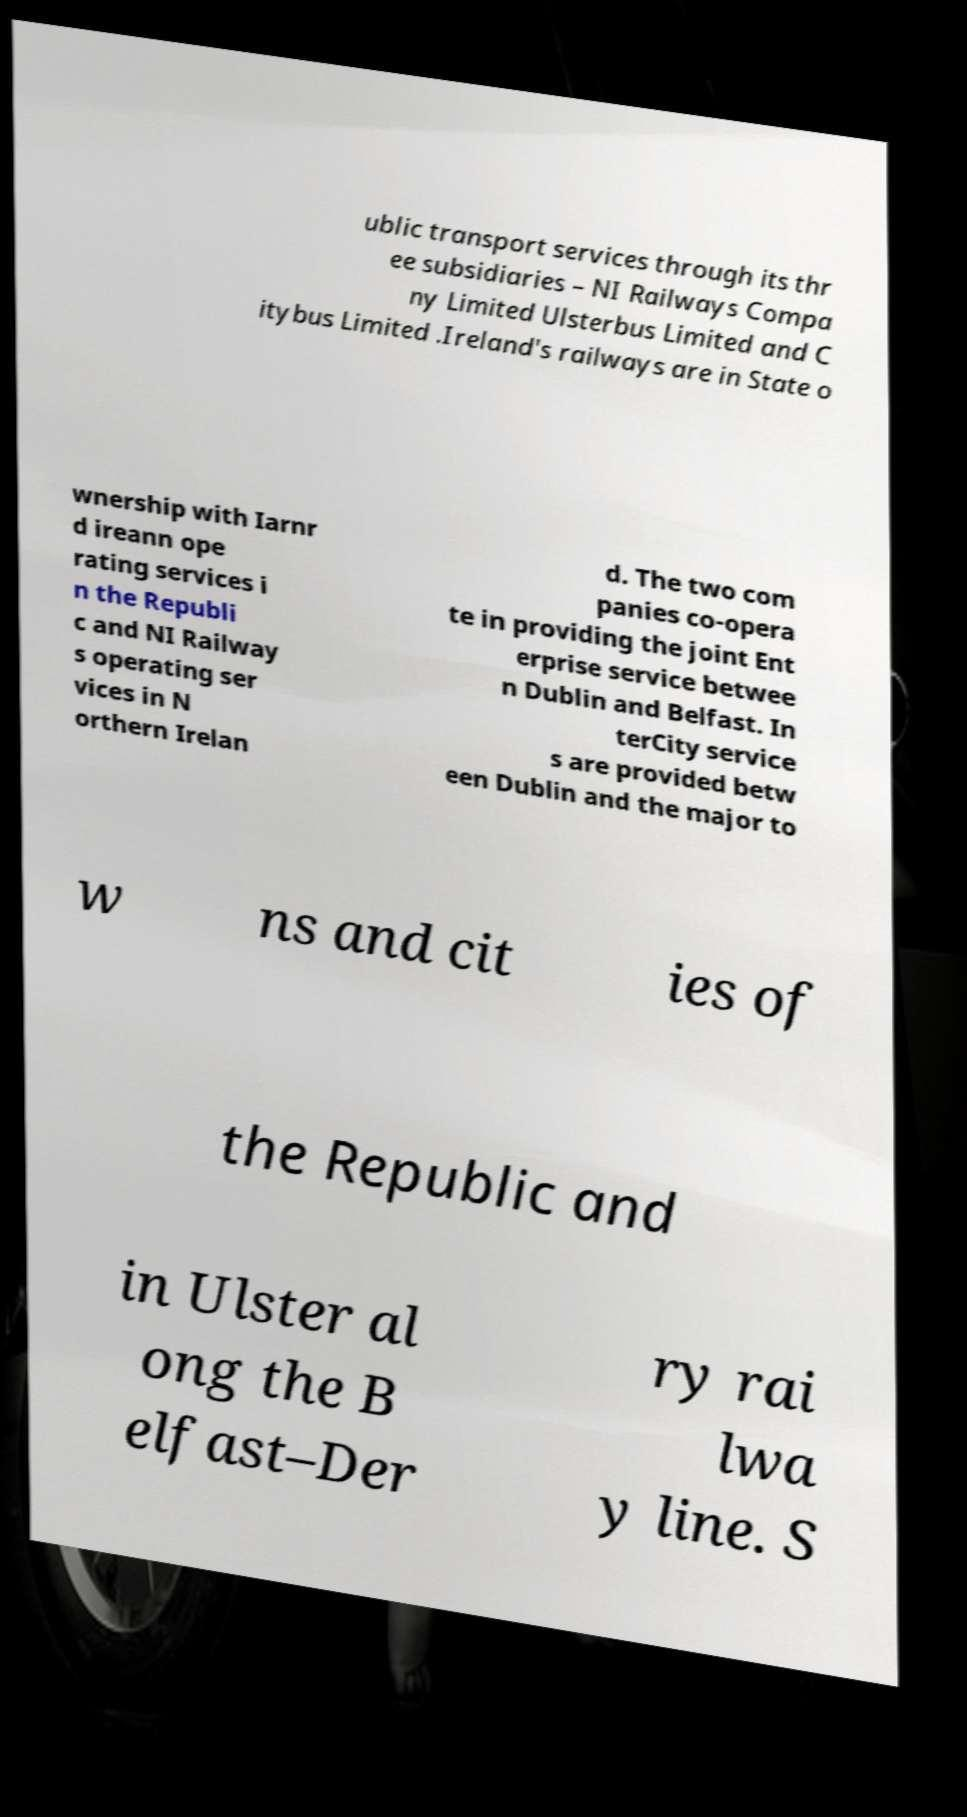Could you assist in decoding the text presented in this image and type it out clearly? ublic transport services through its thr ee subsidiaries – NI Railways Compa ny Limited Ulsterbus Limited and C itybus Limited .Ireland's railways are in State o wnership with Iarnr d ireann ope rating services i n the Republi c and NI Railway s operating ser vices in N orthern Irelan d. The two com panies co-opera te in providing the joint Ent erprise service betwee n Dublin and Belfast. In terCity service s are provided betw een Dublin and the major to w ns and cit ies of the Republic and in Ulster al ong the B elfast–Der ry rai lwa y line. S 